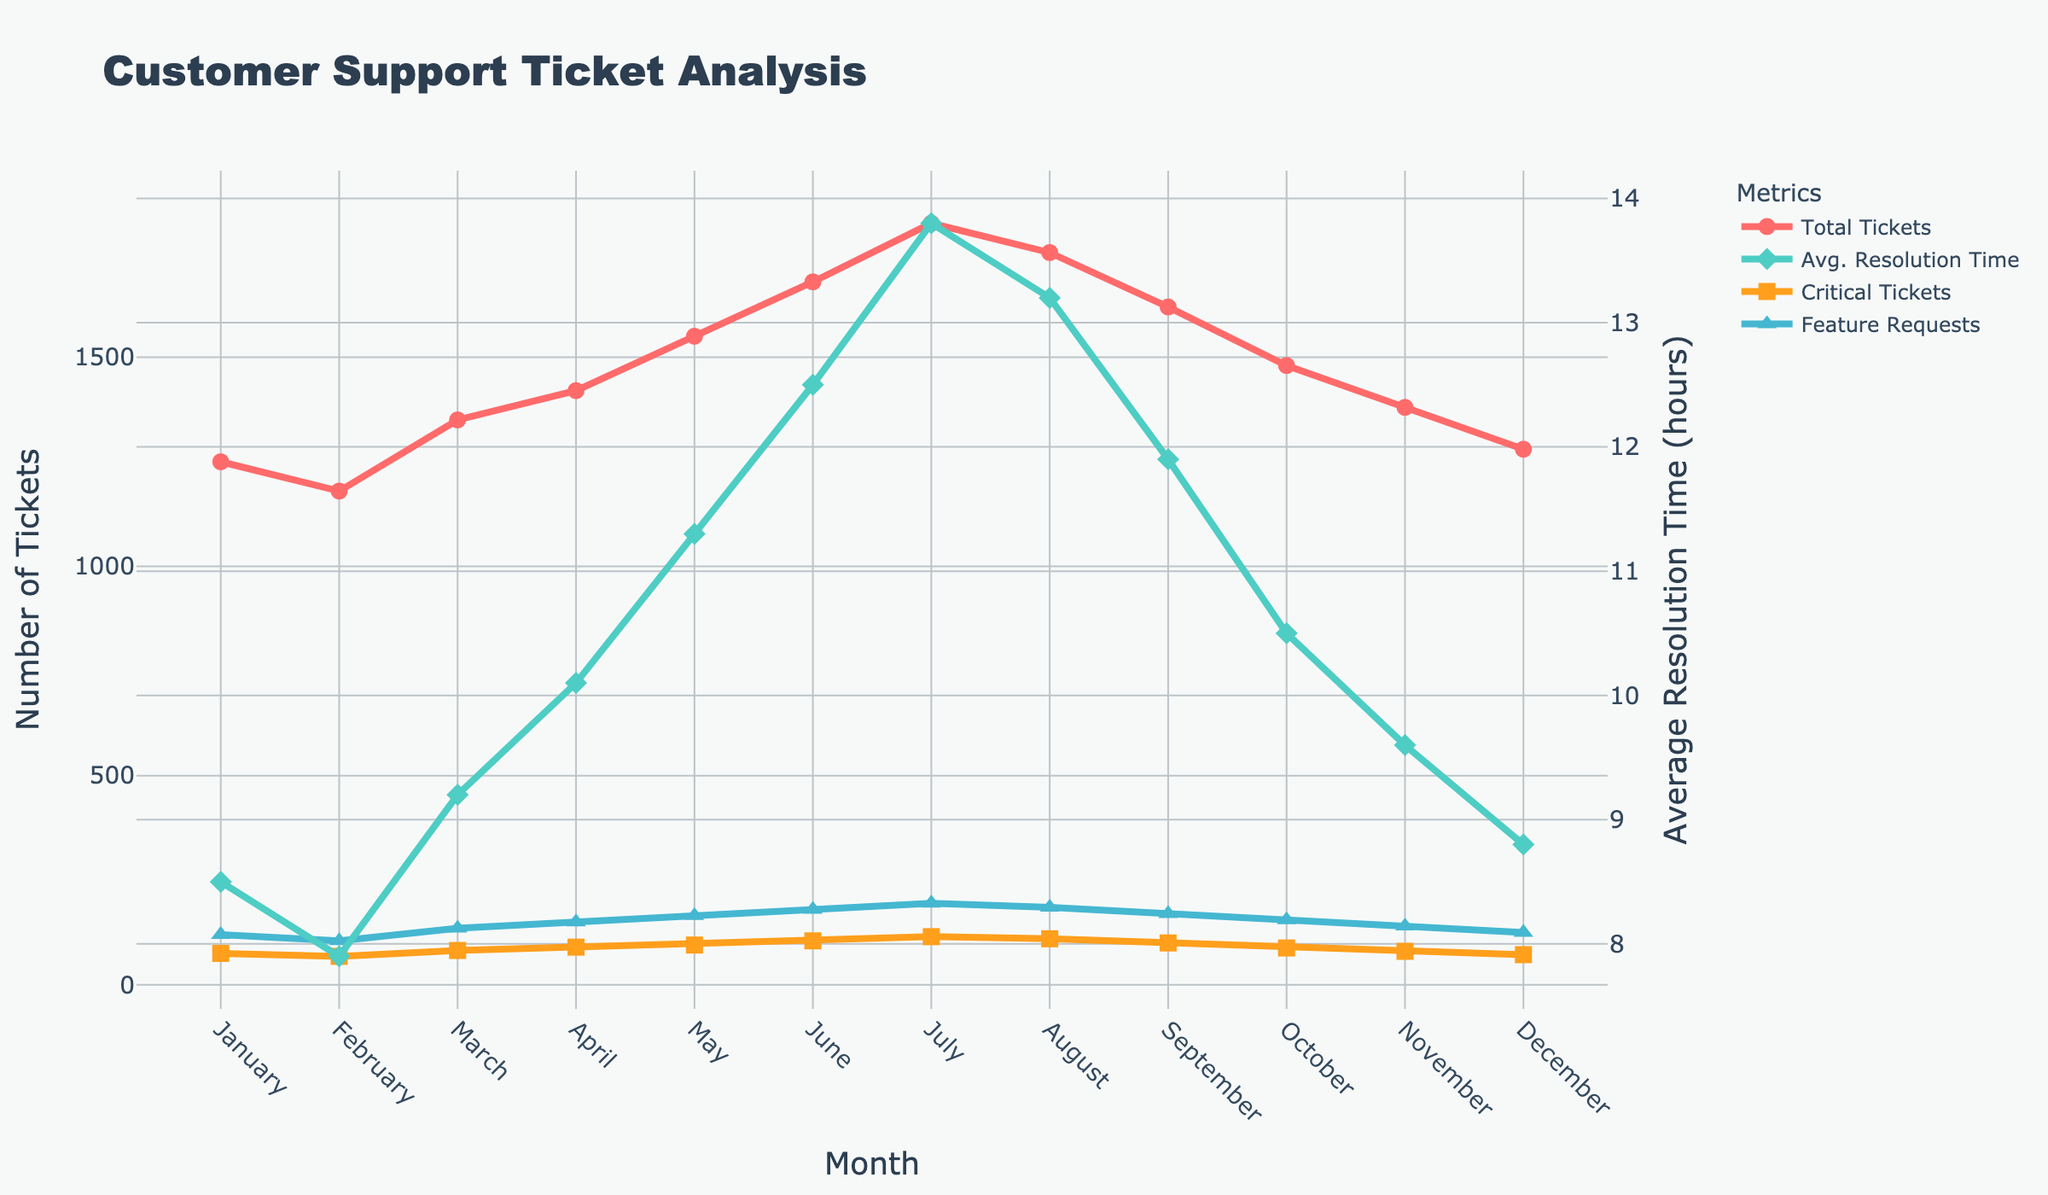What is the month with the highest total number of tickets? We start by observing the 'Total Tickets' line (red) in the chart. The highest point on this line represents the month with the maximum number of tickets.
Answer: July Compare the average resolution time between January and July. Which one is greater? The 'Avg. Resolution Time' line (green) shows the values. We look at January and July points; January has around 8.5 hours, while July is approximately 13.8 hours. July has a higher resolution time.
Answer: July What is the average number of critical tickets for the first six months of the year? We sum the number of critical tickets from January to June (75 + 68 + 82 + 90 + 95 + 105) = 515. Then, we divide by 6.
Answer: 85.83 Which month saw the highest number of Feature Request Tickets and what was the value? By checking the 'Feature Request Tickets' line (blue) in the chart, the peak value is seen. The highest point is in July with a value of 195 tickets.
Answer: July, 195 What is the difference in the number of total tickets between June and December? Looking at the 'Total Tickets' values, June has 1680 tickets, and December has 1280 tickets. Subtract December's total from June's total (1680 - 1280).
Answer: 400 How does the trend of average resolution time correlate with the trend of total tickets over the year? By observing both 'Total Tickets' and 'Avg. Resolution Time' lines, we can see that as the total number of tickets increases, the average resolution time also tends to rise.
Answer: They both increase together During which month does the number of critical tickets exceed the number of feature request tickets? Comparing the 'Critical Tickets' (orange) and 'Feature Request Tickets' (blue) lines, we see that in no month does the number of critical tickets exceed the feature request tickets.
Answer: No month What is the total number of tickets resolved in the last quarter (October to December)? Sum the 'Total Tickets' values for October, November, and December (1480 + 1380 + 1280).
Answer: 4140 What is the average resolution time for the entire second half of the year? Sum the average resolution times from July to December (13.8 + 13.2 + 11.9 + 10.5 + 9.6 + 8.8) = 67.8. Divide this by the number of months (6).
Answer: 11.3 